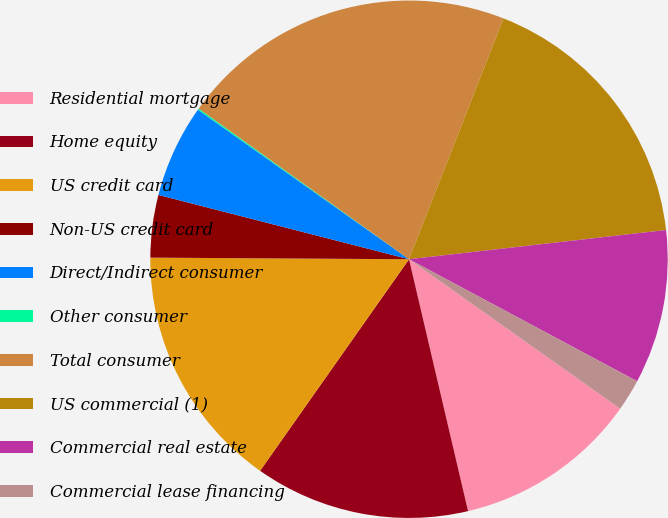Convert chart to OTSL. <chart><loc_0><loc_0><loc_500><loc_500><pie_chart><fcel>Residential mortgage<fcel>Home equity<fcel>US credit card<fcel>Non-US credit card<fcel>Direct/Indirect consumer<fcel>Other consumer<fcel>Total consumer<fcel>US commercial (1)<fcel>Commercial real estate<fcel>Commercial lease financing<nl><fcel>11.53%<fcel>13.43%<fcel>15.34%<fcel>3.9%<fcel>5.81%<fcel>0.09%<fcel>21.06%<fcel>17.25%<fcel>9.62%<fcel>1.99%<nl></chart> 